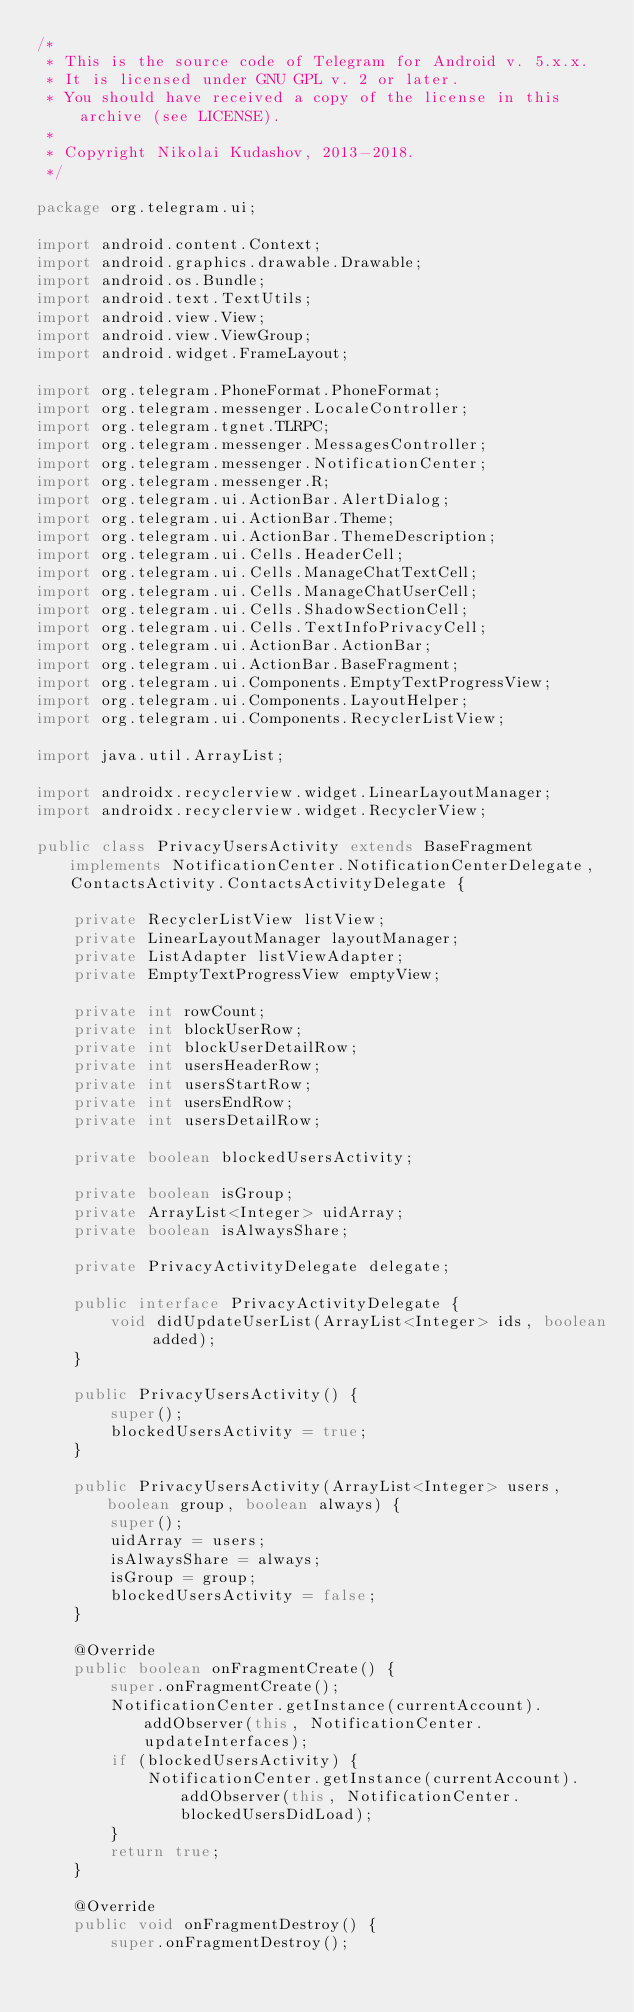<code> <loc_0><loc_0><loc_500><loc_500><_Java_>/*
 * This is the source code of Telegram for Android v. 5.x.x.
 * It is licensed under GNU GPL v. 2 or later.
 * You should have received a copy of the license in this archive (see LICENSE).
 *
 * Copyright Nikolai Kudashov, 2013-2018.
 */

package org.telegram.ui;

import android.content.Context;
import android.graphics.drawable.Drawable;
import android.os.Bundle;
import android.text.TextUtils;
import android.view.View;
import android.view.ViewGroup;
import android.widget.FrameLayout;

import org.telegram.PhoneFormat.PhoneFormat;
import org.telegram.messenger.LocaleController;
import org.telegram.tgnet.TLRPC;
import org.telegram.messenger.MessagesController;
import org.telegram.messenger.NotificationCenter;
import org.telegram.messenger.R;
import org.telegram.ui.ActionBar.AlertDialog;
import org.telegram.ui.ActionBar.Theme;
import org.telegram.ui.ActionBar.ThemeDescription;
import org.telegram.ui.Cells.HeaderCell;
import org.telegram.ui.Cells.ManageChatTextCell;
import org.telegram.ui.Cells.ManageChatUserCell;
import org.telegram.ui.Cells.ShadowSectionCell;
import org.telegram.ui.Cells.TextInfoPrivacyCell;
import org.telegram.ui.ActionBar.ActionBar;
import org.telegram.ui.ActionBar.BaseFragment;
import org.telegram.ui.Components.EmptyTextProgressView;
import org.telegram.ui.Components.LayoutHelper;
import org.telegram.ui.Components.RecyclerListView;

import java.util.ArrayList;

import androidx.recyclerview.widget.LinearLayoutManager;
import androidx.recyclerview.widget.RecyclerView;

public class PrivacyUsersActivity extends BaseFragment implements NotificationCenter.NotificationCenterDelegate, ContactsActivity.ContactsActivityDelegate {

    private RecyclerListView listView;
    private LinearLayoutManager layoutManager;
    private ListAdapter listViewAdapter;
    private EmptyTextProgressView emptyView;

    private int rowCount;
    private int blockUserRow;
    private int blockUserDetailRow;
    private int usersHeaderRow;
    private int usersStartRow;
    private int usersEndRow;
    private int usersDetailRow;

    private boolean blockedUsersActivity;

    private boolean isGroup;
    private ArrayList<Integer> uidArray;
    private boolean isAlwaysShare;

    private PrivacyActivityDelegate delegate;

    public interface PrivacyActivityDelegate {
        void didUpdateUserList(ArrayList<Integer> ids, boolean added);
    }

    public PrivacyUsersActivity() {
        super();
        blockedUsersActivity = true;
    }

    public PrivacyUsersActivity(ArrayList<Integer> users, boolean group, boolean always) {
        super();
        uidArray = users;
        isAlwaysShare = always;
        isGroup = group;
        blockedUsersActivity = false;
    }

    @Override
    public boolean onFragmentCreate() {
        super.onFragmentCreate();
        NotificationCenter.getInstance(currentAccount).addObserver(this, NotificationCenter.updateInterfaces);
        if (blockedUsersActivity) {
            NotificationCenter.getInstance(currentAccount).addObserver(this, NotificationCenter.blockedUsersDidLoad);
        }
        return true;
    }

    @Override
    public void onFragmentDestroy() {
        super.onFragmentDestroy();</code> 